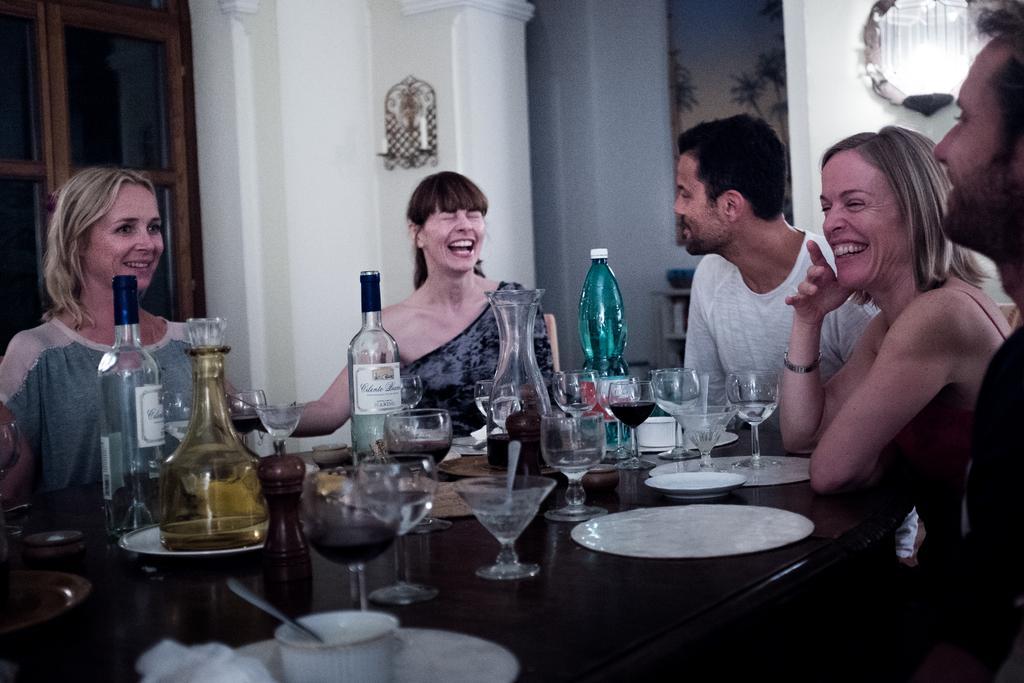Please provide a concise description of this image. In this picture there is a group of person, those who are sitting on the chairs, and there ia a table in between there are bottles, glasses, and plates on the table, it seems to be a happiest moment all are laughing, there is a door at the left side of the image. 